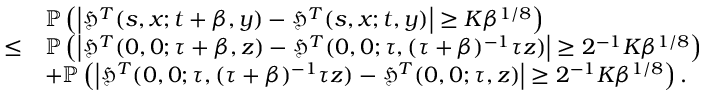<formula> <loc_0><loc_0><loc_500><loc_500>\begin{array} { r l } & { \mathbb { P } \left ( \left | \mathfrak { H } ^ { T } ( s , x ; t + \beta , y ) - \mathfrak { H } ^ { T } ( s , x ; t , y ) \right | \geq K \beta ^ { 1 / 8 } \right ) } \\ { \leq } & { \mathbb { P } \left ( \left | \mathfrak { H } ^ { T } ( 0 , 0 ; \tau + \beta , z ) - \mathfrak { H } ^ { T } ( 0 , 0 ; \tau , ( \tau + \beta ) ^ { - 1 } \tau z ) \right | \geq 2 ^ { - 1 } K \beta ^ { 1 / 8 } \right ) } \\ & { + \mathbb { P } \left ( \left | \mathfrak { H } ^ { T } ( 0 , 0 ; \tau , ( \tau + \beta ) ^ { - 1 } \tau z ) - \mathfrak { H } ^ { T } ( 0 , 0 ; \tau , z ) \right | \geq 2 ^ { - 1 } K \beta ^ { 1 / 8 } \right ) . } \end{array}</formula> 